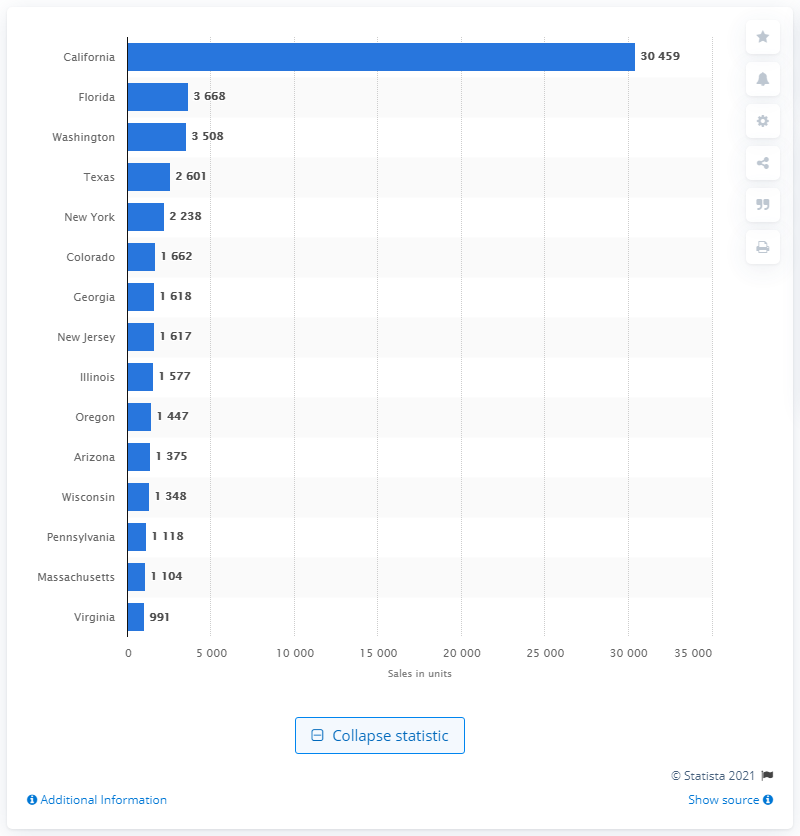Indicate a few pertinent items in this graphic. Florida sold approximately 3,670 battery-electric vehicles (BEVs) in 2016, making it the state that sold the highest number of BEVs that year. California is the leading state in terms of BEV sales. 